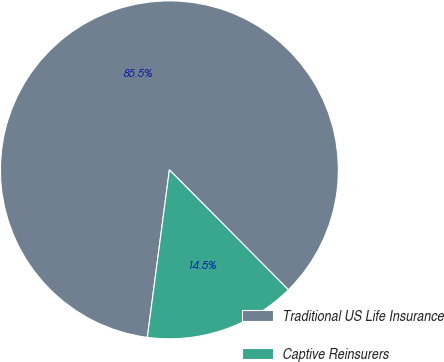<chart> <loc_0><loc_0><loc_500><loc_500><pie_chart><fcel>Traditional US Life Insurance<fcel>Captive Reinsurers<nl><fcel>85.48%<fcel>14.52%<nl></chart> 